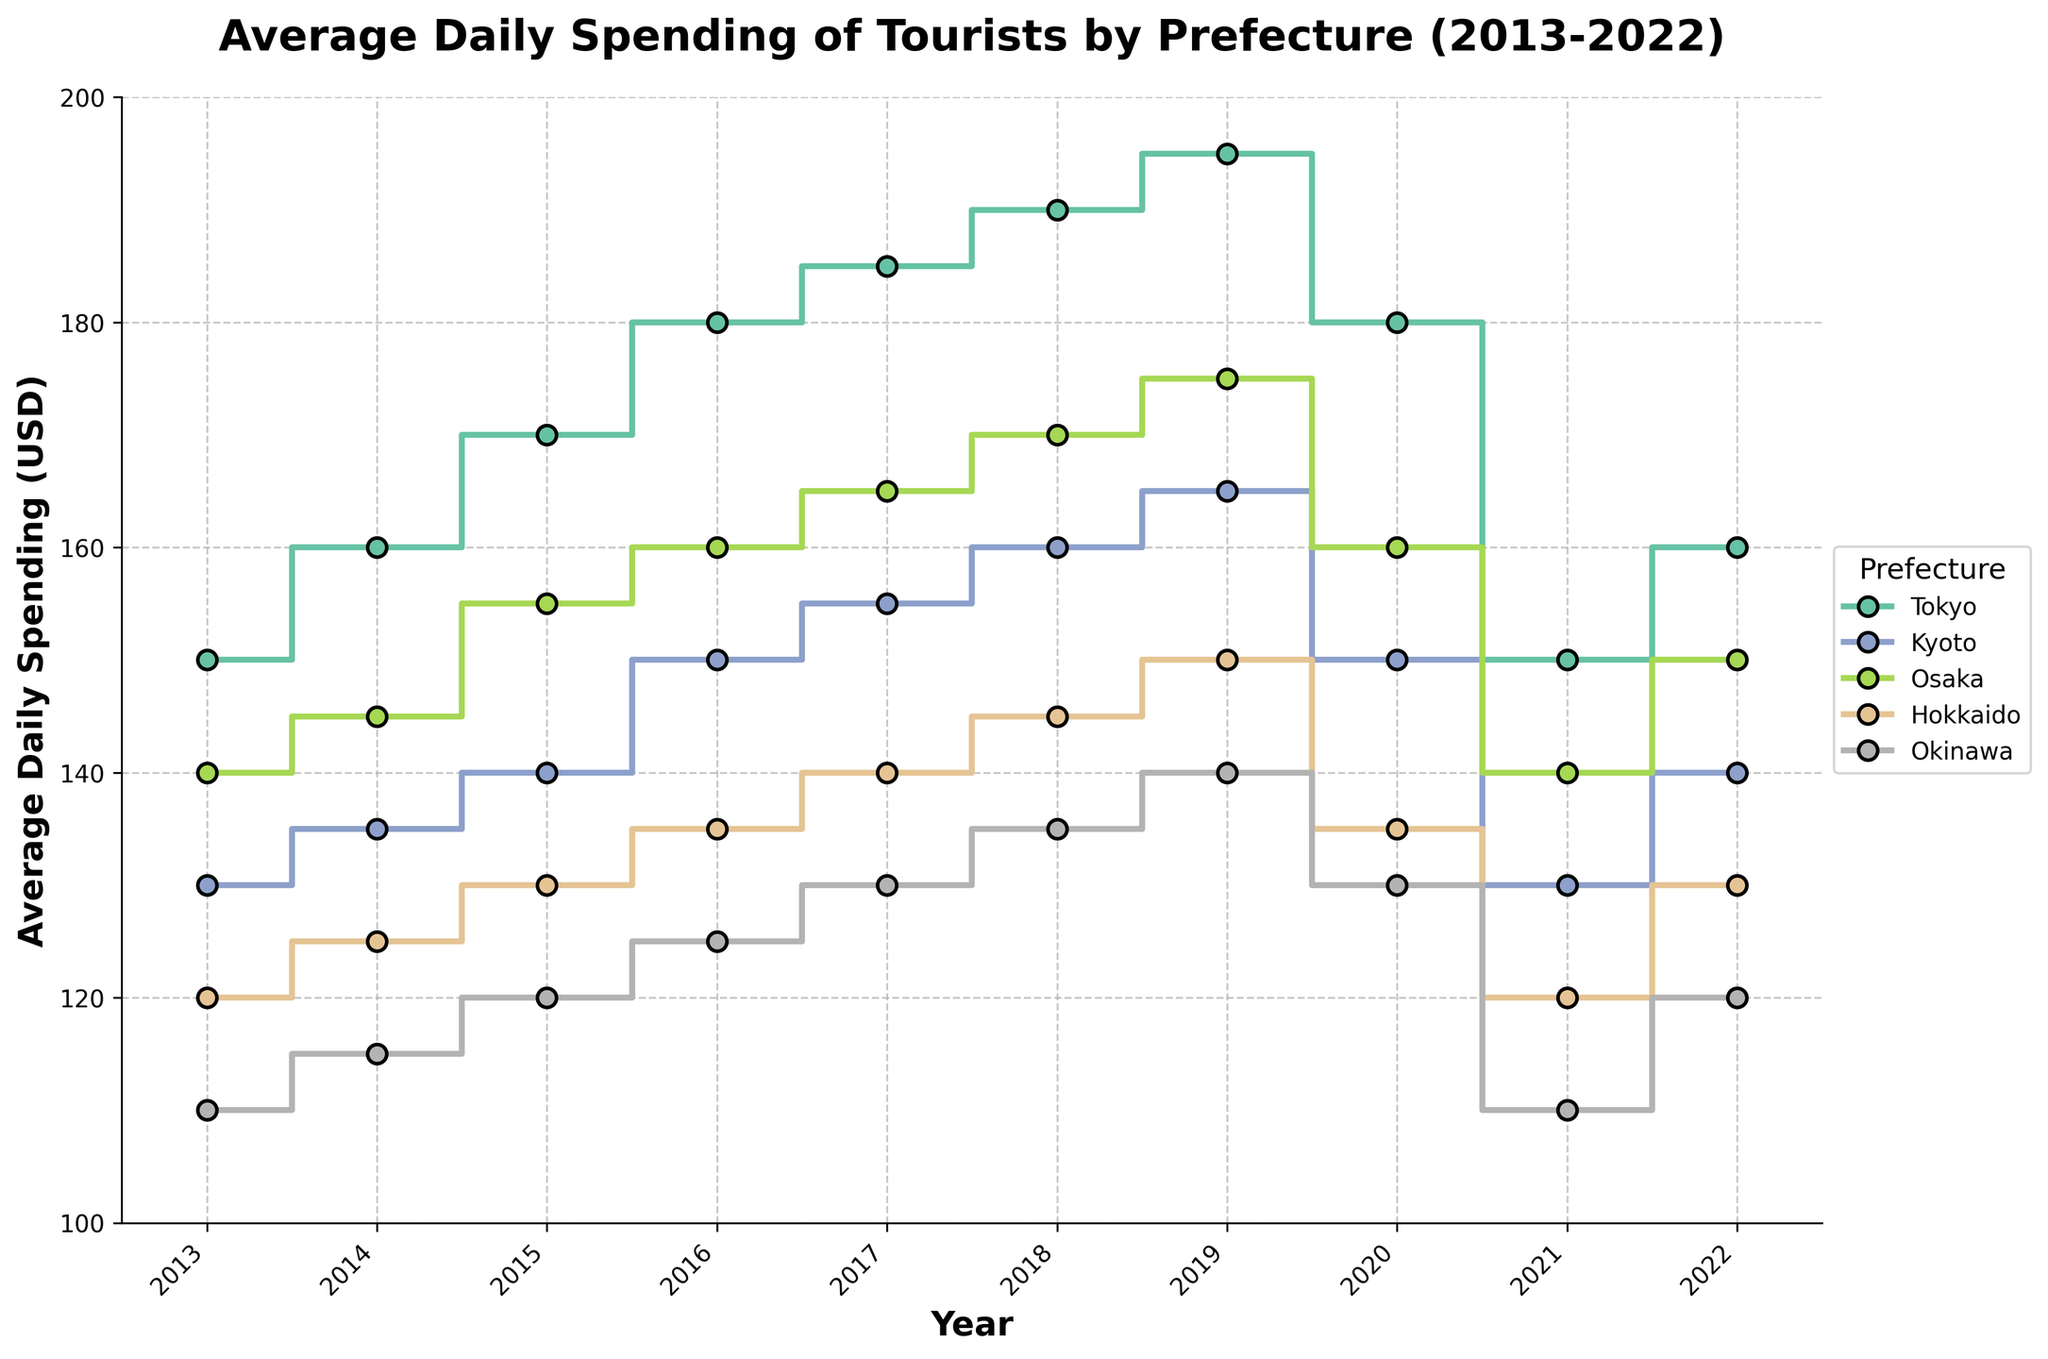What's the title of the figure? The title is located at the top center of the figure and reads "Average Daily Spending of Tourists by Prefecture (2013-2022)"
Answer: Average Daily Spending of Tourists by Prefecture (2013-2022) What is the average daily spending in Tokyo in 2022? Locate the 2022 value on the Tokyo line in the plot, it intersects at the average daily spending of 160 USD
Answer: 160 USD Which prefecture had the highest average daily spending in 2017? Compare the values for all prefectures in 2017: Tokyo (185), Kyoto (155), Osaka (165), Hokkaido (140), and Okinawa (130). Tokyo has the highest value
Answer: Tokyo What is the difference in average daily spending between Kyoto and Okinawa in 2022? In 2022, Kyoto's spending is 140 USD and Okinawa's is 120 USD. The difference is 140 - 120
Answer: 20 USD How did the average daily spending in Hokkaido change from 2013 to 2022? In 2013, Hokkaido's spending was 120 USD, and in 2022 it was 130 USD. The change is 130 - 120
Answer: Increased by 10 USD Which prefecture saw a drop in average daily spending between 2019 and 2020? Compare 2019 and 2020 values for each prefecture. All saw drops: Tokyo (195 to 180), Kyoto (165 to 150), Osaka (175 to 160), Hokkaido (150 to 135), Okinawa (140 to 130)
Answer: All prefectures Was Tokyo's average daily spending higher or lower in 2021 compared to 2020? Tokyo’s spending in 2021 is 150 USD, and in 2020 it was 180 USD. Since 150 < 180, it was lower in 2021
Answer: Lower What was the trend in average daily spending for Osaka between 2013 and 2019? Trace the line for Osaka from 2013 (140 USD) to 2019 (175 USD); there is a steady increase over the years
Answer: Increasing trend Between which years did Okinawa see the largest decrease in average daily spending? The largest decrease is between 2019 (140 USD) and 2020 (130 USD) where the difference is 10 USD
Answer: 2019 to 2020 In which year did Kyoto have an average daily spending of 140 USD? Locate the point on Kyoto's line where it intersects at 140 USD; this occurs in the year 2015
Answer: 2015 